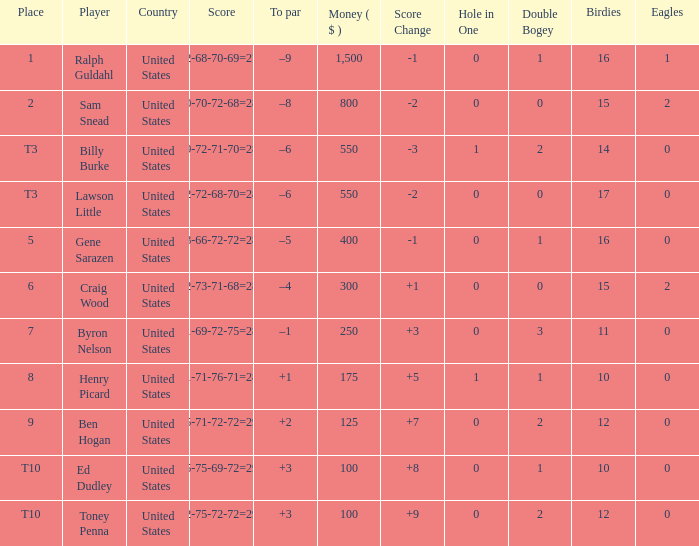Which country has a prize smaller than $250 and the player Henry Picard? United States. 